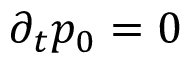<formula> <loc_0><loc_0><loc_500><loc_500>\partial _ { t } p _ { 0 } = 0</formula> 